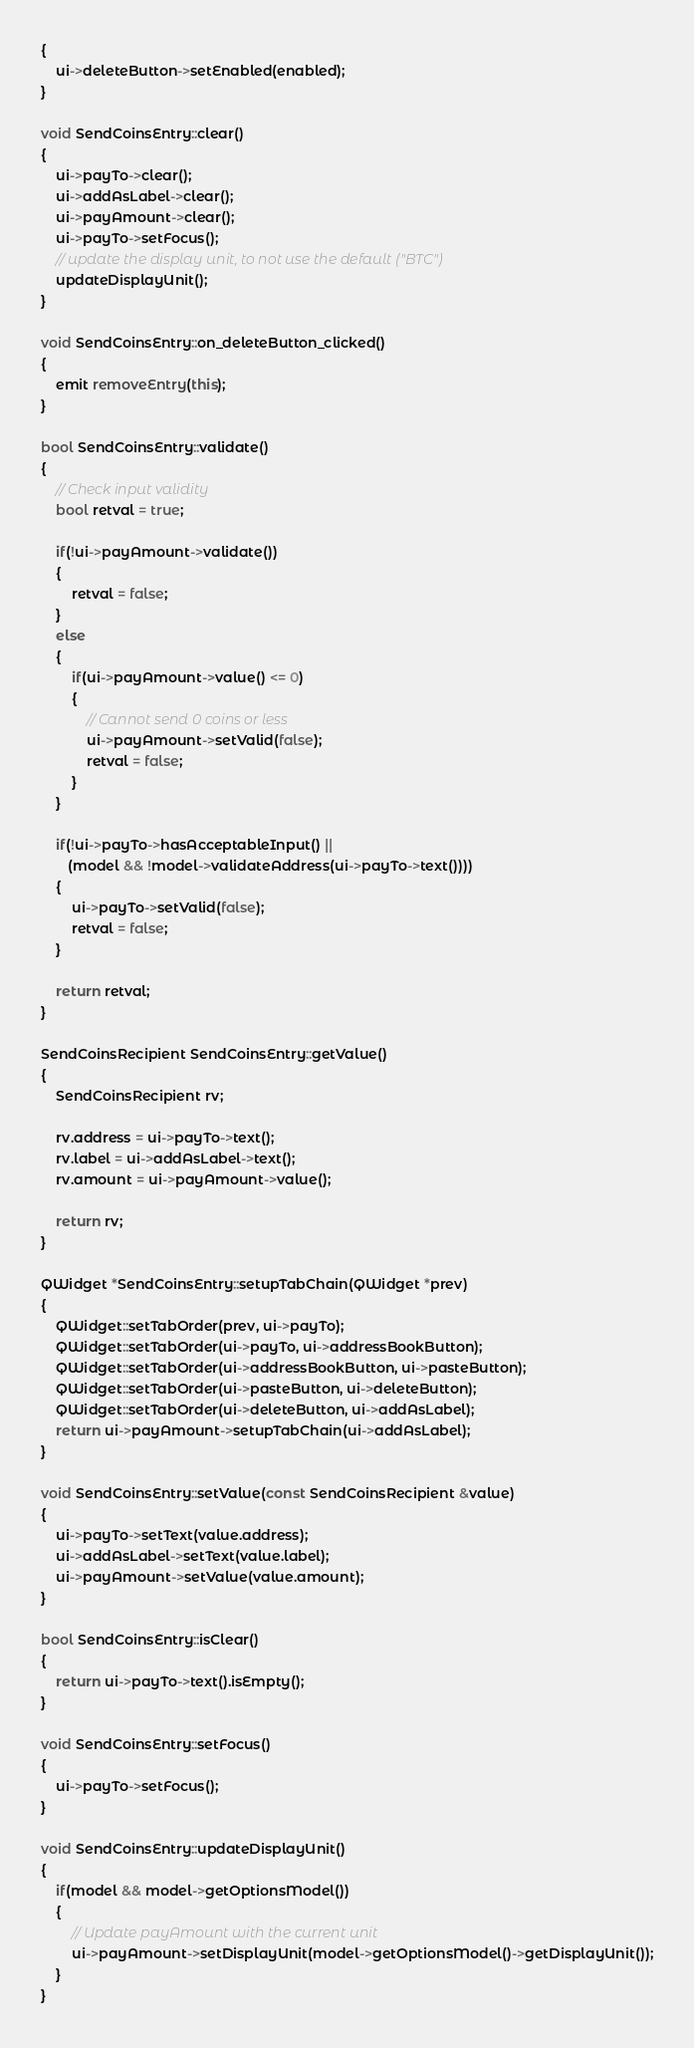Convert code to text. <code><loc_0><loc_0><loc_500><loc_500><_C++_>{
    ui->deleteButton->setEnabled(enabled);
}

void SendCoinsEntry::clear()
{
    ui->payTo->clear();
    ui->addAsLabel->clear();
    ui->payAmount->clear();
    ui->payTo->setFocus();
    // update the display unit, to not use the default ("BTC")
    updateDisplayUnit();
}

void SendCoinsEntry::on_deleteButton_clicked()
{
    emit removeEntry(this);
}

bool SendCoinsEntry::validate()
{
    // Check input validity
    bool retval = true;

    if(!ui->payAmount->validate())
    {
        retval = false;
    }
    else
    {
        if(ui->payAmount->value() <= 0)
        {
            // Cannot send 0 coins or less
            ui->payAmount->setValid(false);
            retval = false;
        }
    }

    if(!ui->payTo->hasAcceptableInput() ||
       (model && !model->validateAddress(ui->payTo->text())))
    {
        ui->payTo->setValid(false);
        retval = false;
    }

    return retval;
}

SendCoinsRecipient SendCoinsEntry::getValue()
{
    SendCoinsRecipient rv;

    rv.address = ui->payTo->text();
    rv.label = ui->addAsLabel->text();
    rv.amount = ui->payAmount->value();

    return rv;
}

QWidget *SendCoinsEntry::setupTabChain(QWidget *prev)
{
    QWidget::setTabOrder(prev, ui->payTo);
    QWidget::setTabOrder(ui->payTo, ui->addressBookButton);
    QWidget::setTabOrder(ui->addressBookButton, ui->pasteButton);
    QWidget::setTabOrder(ui->pasteButton, ui->deleteButton);
    QWidget::setTabOrder(ui->deleteButton, ui->addAsLabel);
    return ui->payAmount->setupTabChain(ui->addAsLabel);
}

void SendCoinsEntry::setValue(const SendCoinsRecipient &value)
{
    ui->payTo->setText(value.address);
    ui->addAsLabel->setText(value.label);
    ui->payAmount->setValue(value.amount);
}

bool SendCoinsEntry::isClear()
{
    return ui->payTo->text().isEmpty();
}

void SendCoinsEntry::setFocus()
{
    ui->payTo->setFocus();
}

void SendCoinsEntry::updateDisplayUnit()
{
    if(model && model->getOptionsModel())
    {
        // Update payAmount with the current unit
        ui->payAmount->setDisplayUnit(model->getOptionsModel()->getDisplayUnit());
    }
}
</code> 